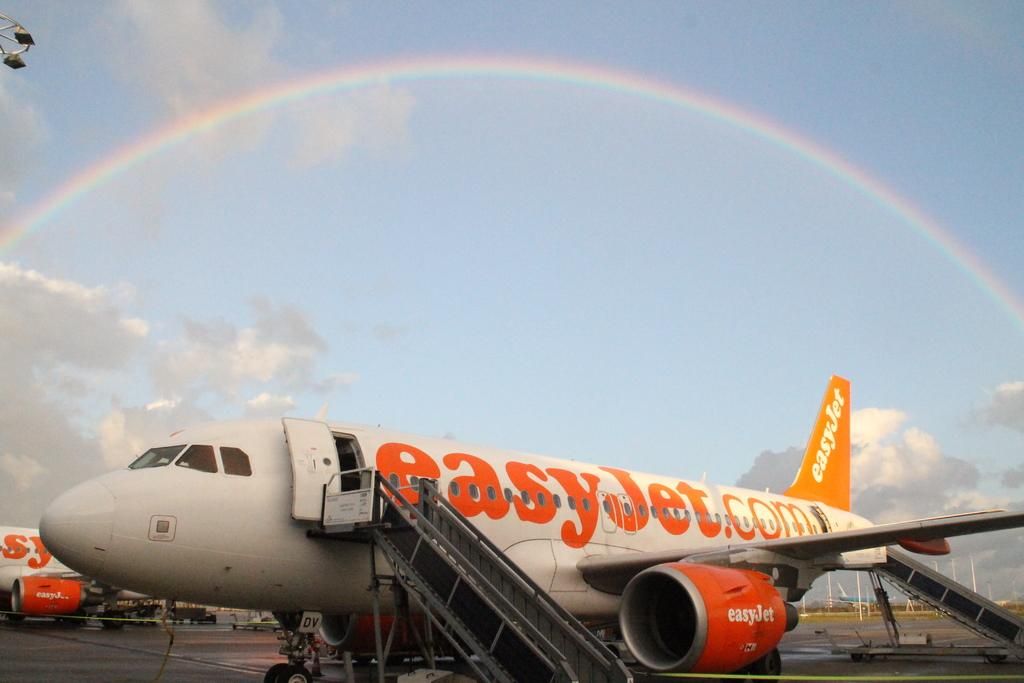What is the main subject of the picture? The main subject of the picture is a flight. Are there any other flights visible in the image? Yes, there is another flight beside the first flight. What can be seen in the background of the image? The sky is visible in the background of the image. What are the weather conditions like in the image? The sky contains clouds and a rainbow, suggesting partly cloudy weather. What type of zephyr can be seen blowing through the crops in the image? There is no zephyr or crops present in the image; it features two flights and a sky with clouds and a rainbow. What is the farmer doing in the image? There is no farmer present in the image. 